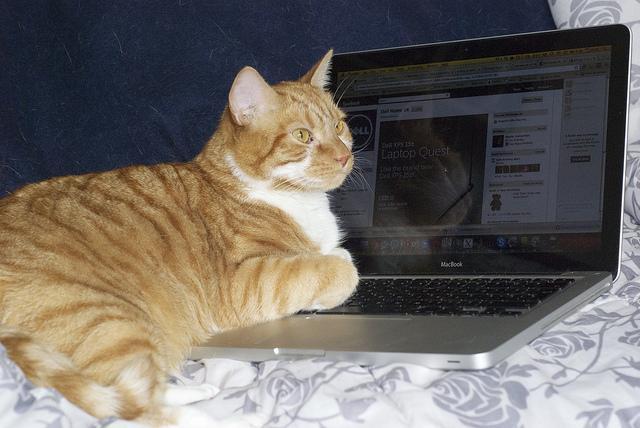How many cats are there?
Give a very brief answer. 1. How many people are wearing red?
Give a very brief answer. 0. 